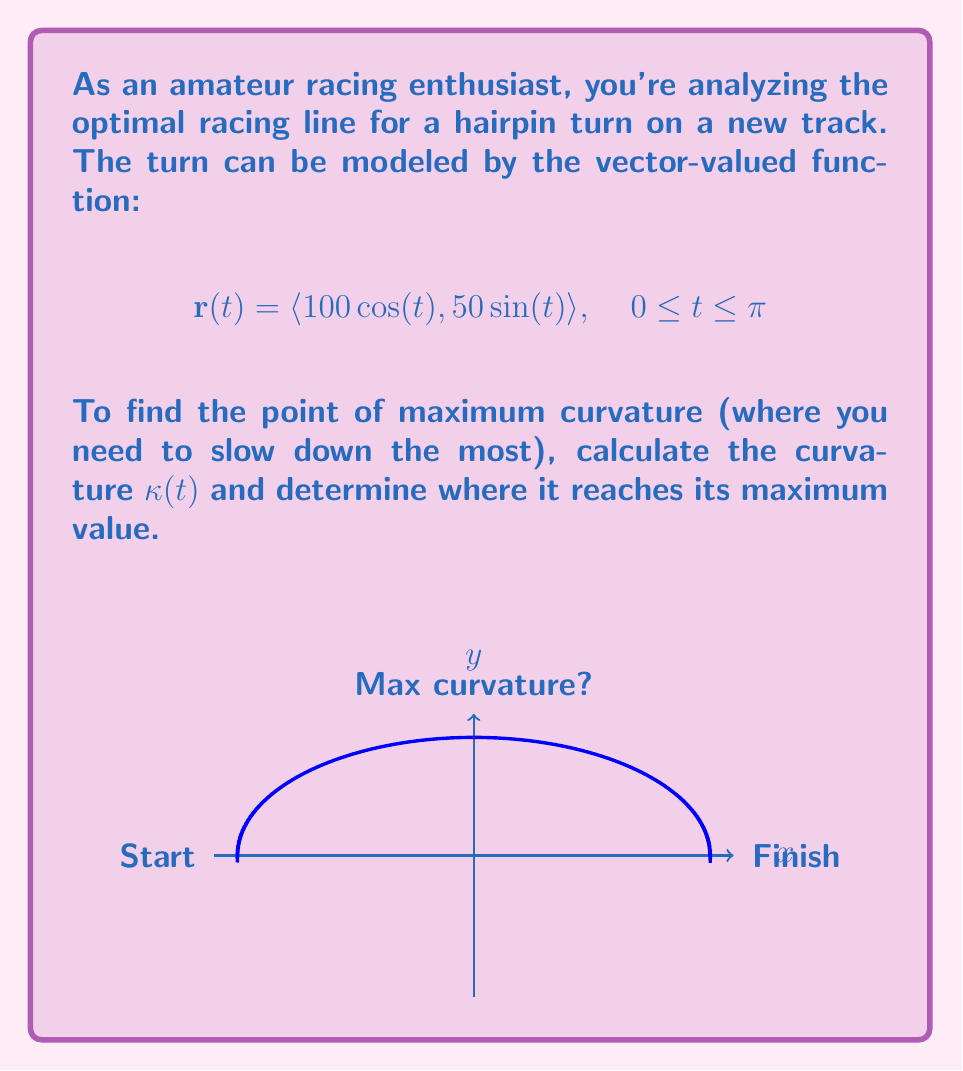Provide a solution to this math problem. To find the point of maximum curvature, we need to follow these steps:

1) First, calculate $\mathbf{r}'(t)$ and $\mathbf{r}''(t)$:
   $$\mathbf{r}'(t) = \langle -100\sin(t), 50\cos(t) \rangle$$
   $$\mathbf{r}''(t) = \langle -100\cos(t), -50\sin(t) \rangle$$

2) The curvature formula for a vector-valued function is:
   $$\kappa(t) = \frac{|\mathbf{r}'(t) \times \mathbf{r}''(t)|}{|\mathbf{r}'(t)|^3}$$

3) Calculate the cross product $\mathbf{r}'(t) \times \mathbf{r}''(t)$:
   $$\mathbf{r}'(t) \times \mathbf{r}''(t) = (-100\sin(t))(-50\sin(t)) - (50\cos(t))(-100\cos(t))$$
   $$= 5000\sin^2(t) + 5000\cos^2(t) = 5000$$

4) Calculate $|\mathbf{r}'(t)|$:
   $$|\mathbf{r}'(t)| = \sqrt{(-100\sin(t))^2 + (50\cos(t))^2} = \sqrt{10000\sin^2(t) + 2500\cos^2(t)}$$

5) Now we can write the curvature function:
   $$\kappa(t) = \frac{5000}{(10000\sin^2(t) + 2500\cos^2(t))^{3/2}}$$

6) To find the maximum, we can differentiate κ(t) and set it to zero. However, we can observe that the denominator is minimized when $\sin^2(t) = 0$ and $\cos^2(t) = 1$, which occurs at $t = 0$ or $t = \pi$.

7) The maximum curvature occurs at $t = \pi/2$, where $\sin^2(t) = 1$ and $\cos^2(t) = 0$.

8) At this point, $\mathbf{r}(\pi/2) = \langle 0, 50 \rangle$.

Therefore, the point of maximum curvature is at (0, 50), which is the apex of the turn.
Answer: (0, 50) 